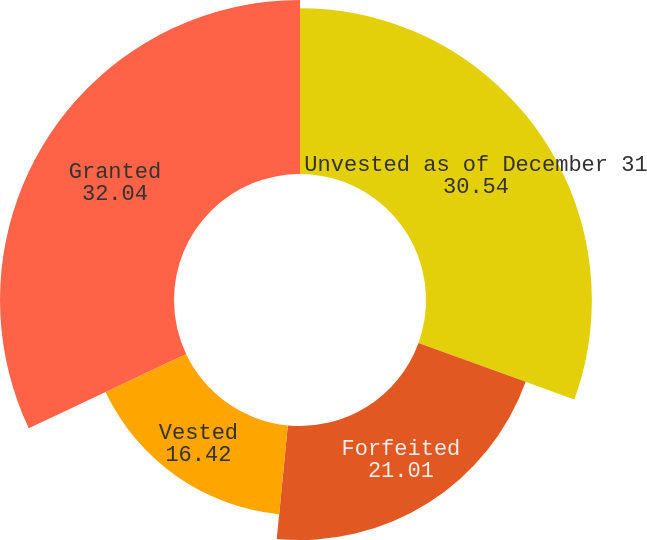Convert chart. <chart><loc_0><loc_0><loc_500><loc_500><pie_chart><fcel>Unvested as of December 31<fcel>Forfeited<fcel>Vested<fcel>Granted<nl><fcel>30.54%<fcel>21.01%<fcel>16.42%<fcel>32.04%<nl></chart> 